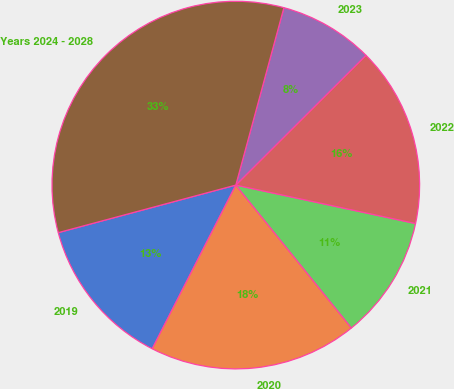<chart> <loc_0><loc_0><loc_500><loc_500><pie_chart><fcel>2019<fcel>2020<fcel>2021<fcel>2022<fcel>2023<fcel>Years 2024 - 2028<nl><fcel>13.32%<fcel>18.34%<fcel>10.82%<fcel>15.83%<fcel>8.31%<fcel>33.38%<nl></chart> 